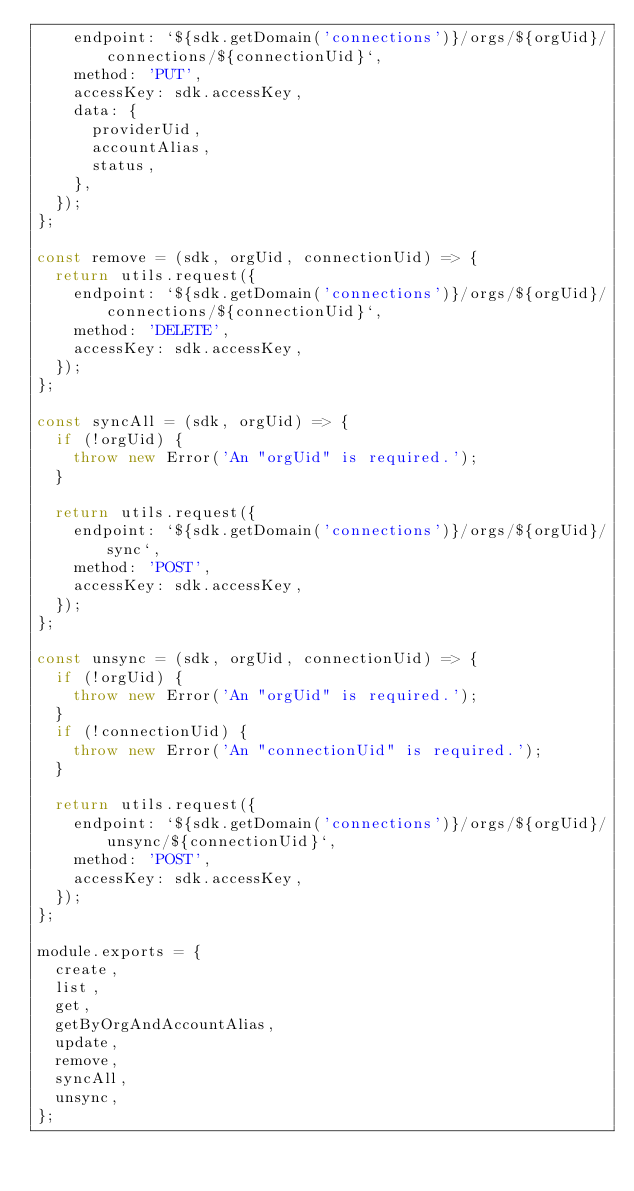Convert code to text. <code><loc_0><loc_0><loc_500><loc_500><_JavaScript_>    endpoint: `${sdk.getDomain('connections')}/orgs/${orgUid}/connections/${connectionUid}`,
    method: 'PUT',
    accessKey: sdk.accessKey,
    data: {
      providerUid,
      accountAlias,
      status,
    },
  });
};

const remove = (sdk, orgUid, connectionUid) => {
  return utils.request({
    endpoint: `${sdk.getDomain('connections')}/orgs/${orgUid}/connections/${connectionUid}`,
    method: 'DELETE',
    accessKey: sdk.accessKey,
  });
};

const syncAll = (sdk, orgUid) => {
  if (!orgUid) {
    throw new Error('An "orgUid" is required.');
  }

  return utils.request({
    endpoint: `${sdk.getDomain('connections')}/orgs/${orgUid}/sync`,
    method: 'POST',
    accessKey: sdk.accessKey,
  });
};

const unsync = (sdk, orgUid, connectionUid) => {
  if (!orgUid) {
    throw new Error('An "orgUid" is required.');
  }
  if (!connectionUid) {
    throw new Error('An "connectionUid" is required.');
  }

  return utils.request({
    endpoint: `${sdk.getDomain('connections')}/orgs/${orgUid}/unsync/${connectionUid}`,
    method: 'POST',
    accessKey: sdk.accessKey,
  });
};

module.exports = {
  create,
  list,
  get,
  getByOrgAndAccountAlias,
  update,
  remove,
  syncAll,
  unsync,
};
</code> 